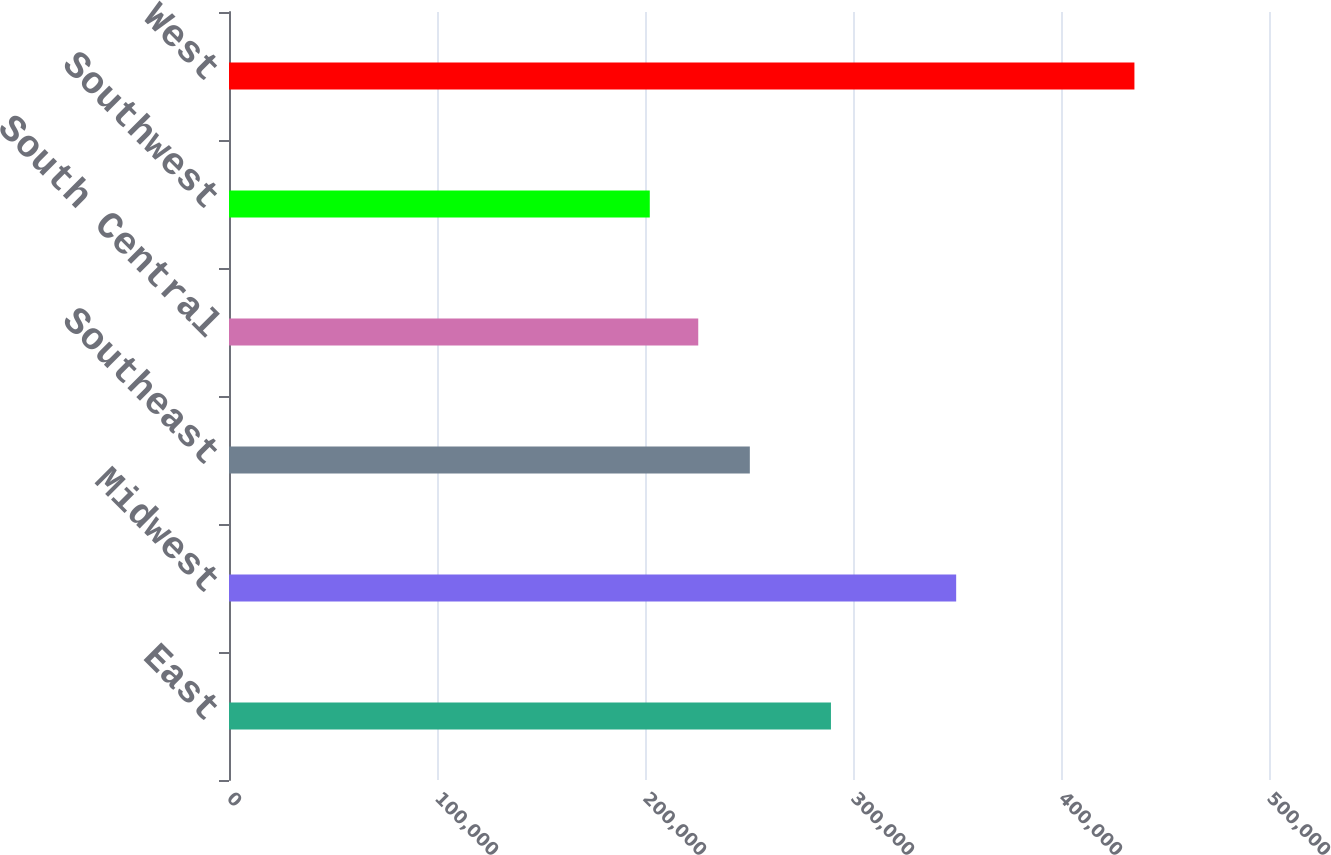Convert chart. <chart><loc_0><loc_0><loc_500><loc_500><bar_chart><fcel>East<fcel>Midwest<fcel>Southeast<fcel>South Central<fcel>Southwest<fcel>West<nl><fcel>289400<fcel>349600<fcel>250400<fcel>225600<fcel>202300<fcel>435300<nl></chart> 